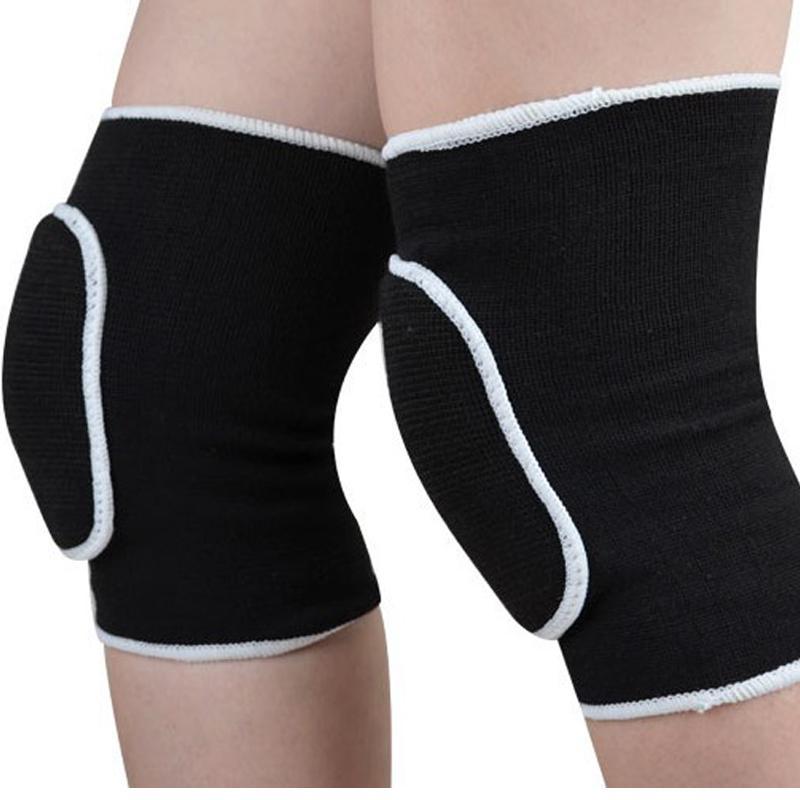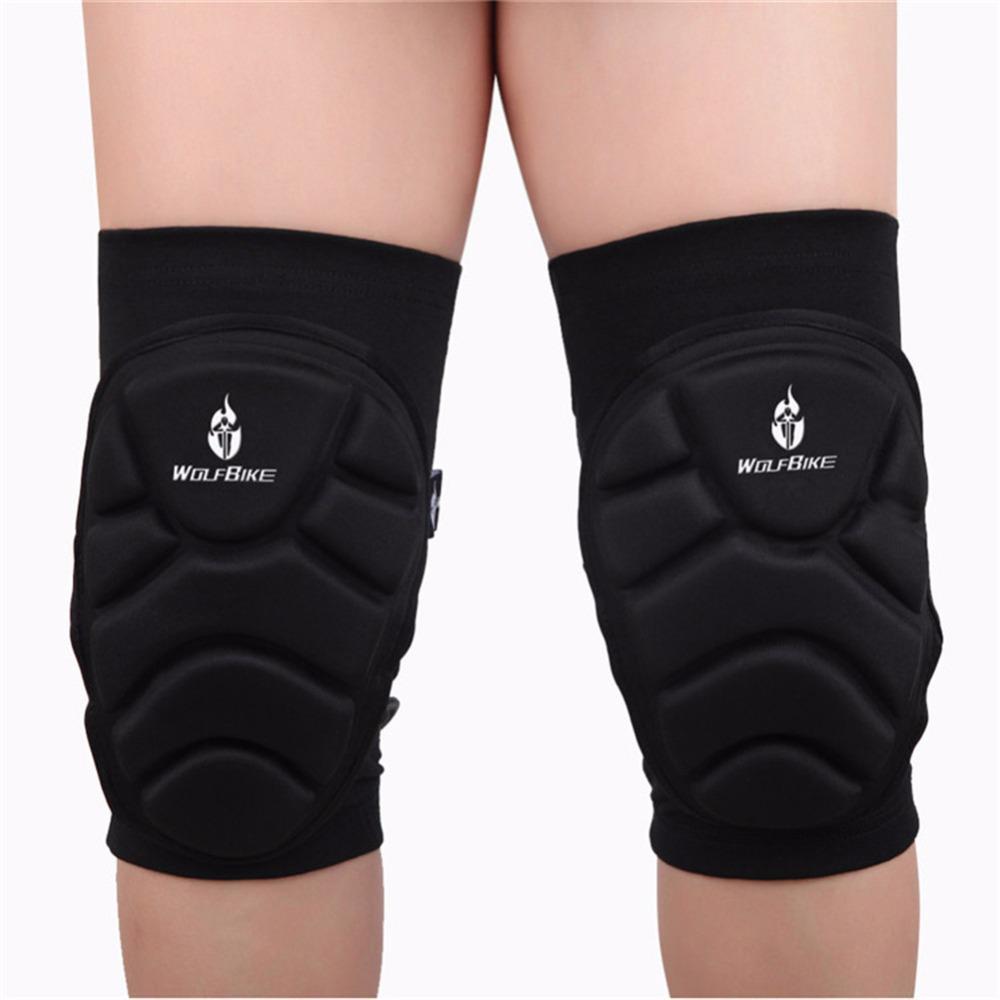The first image is the image on the left, the second image is the image on the right. For the images displayed, is the sentence "There are two sets of matching knee pads being worn by two people." factually correct? Answer yes or no. Yes. The first image is the image on the left, the second image is the image on the right. Considering the images on both sides, is "In total, there are 4 knees covered by black knee guards." valid? Answer yes or no. Yes. 